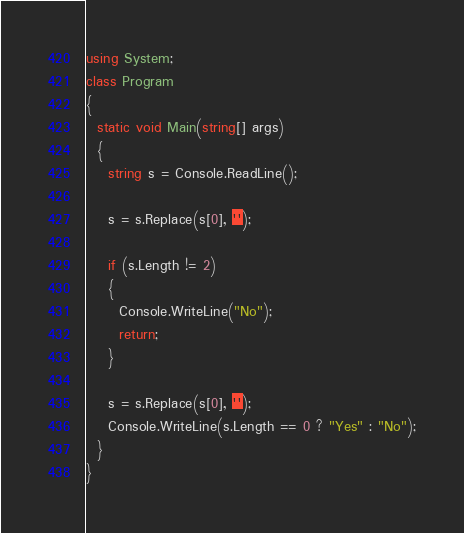<code> <loc_0><loc_0><loc_500><loc_500><_C#_>using System;
class Program
{
  static void Main(string[] args)
  {
    string s = Console.ReadLine();
    
    s = s.Replace(s[0], '');
    
    if (s.Length != 2)
    {
      Console.WriteLine("No");
      return;
    }
    
    s = s.Replace(s[0], '');
    Console.WriteLine(s.Length == 0 ? "Yes" : "No");
  }
}
</code> 